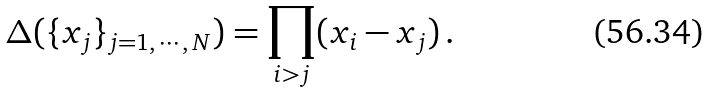<formula> <loc_0><loc_0><loc_500><loc_500>\Delta ( \{ x _ { j } \} _ { j = 1 , \, \cdots , \, N } ) = \prod _ { i > j } ( x _ { i } - x _ { j } ) \, .</formula> 